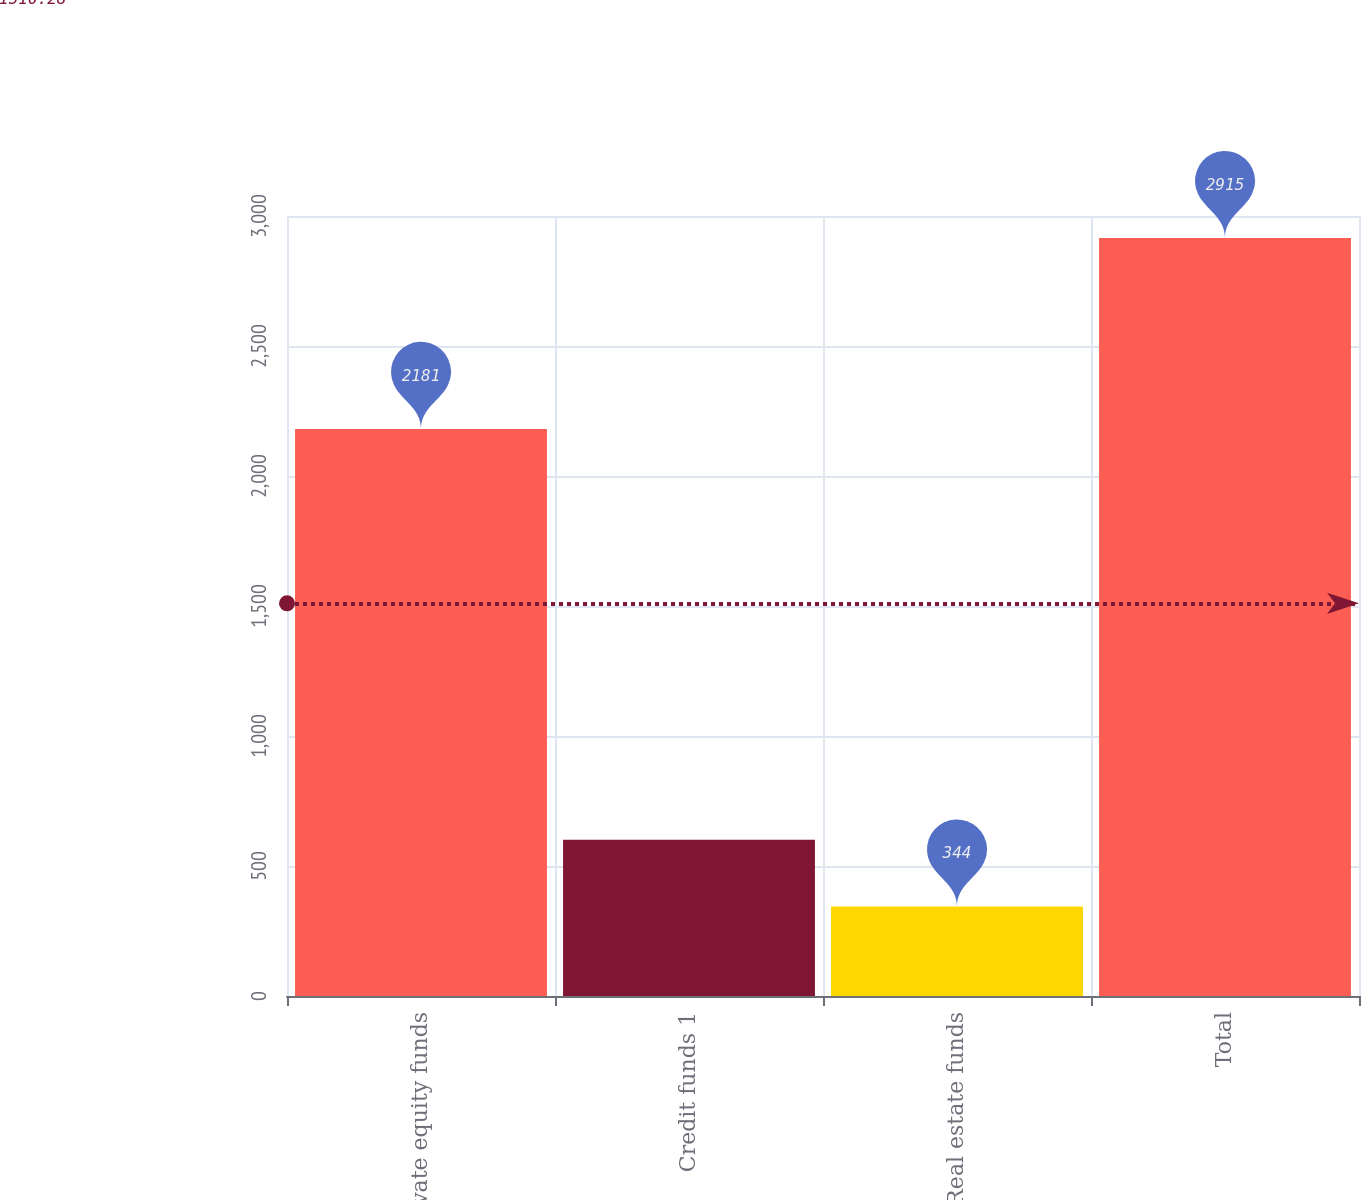Convert chart to OTSL. <chart><loc_0><loc_0><loc_500><loc_500><bar_chart><fcel>Private equity funds<fcel>Credit funds 1<fcel>Real estate funds<fcel>Total<nl><fcel>2181<fcel>601.1<fcel>344<fcel>2915<nl></chart> 